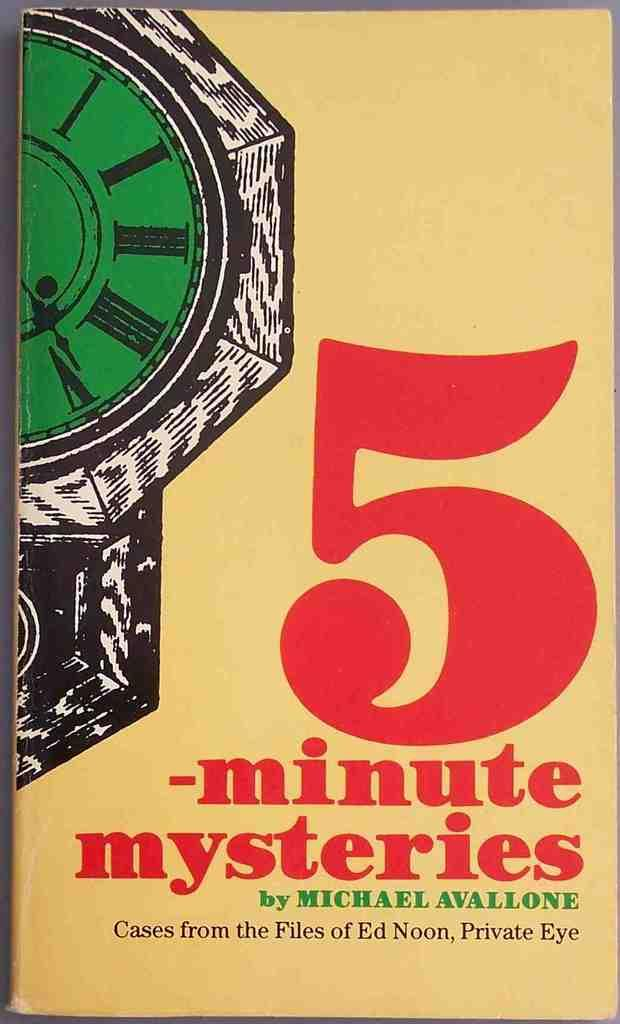<image>
Offer a succinct explanation of the picture presented. a book that is called 5 minute mysteries 